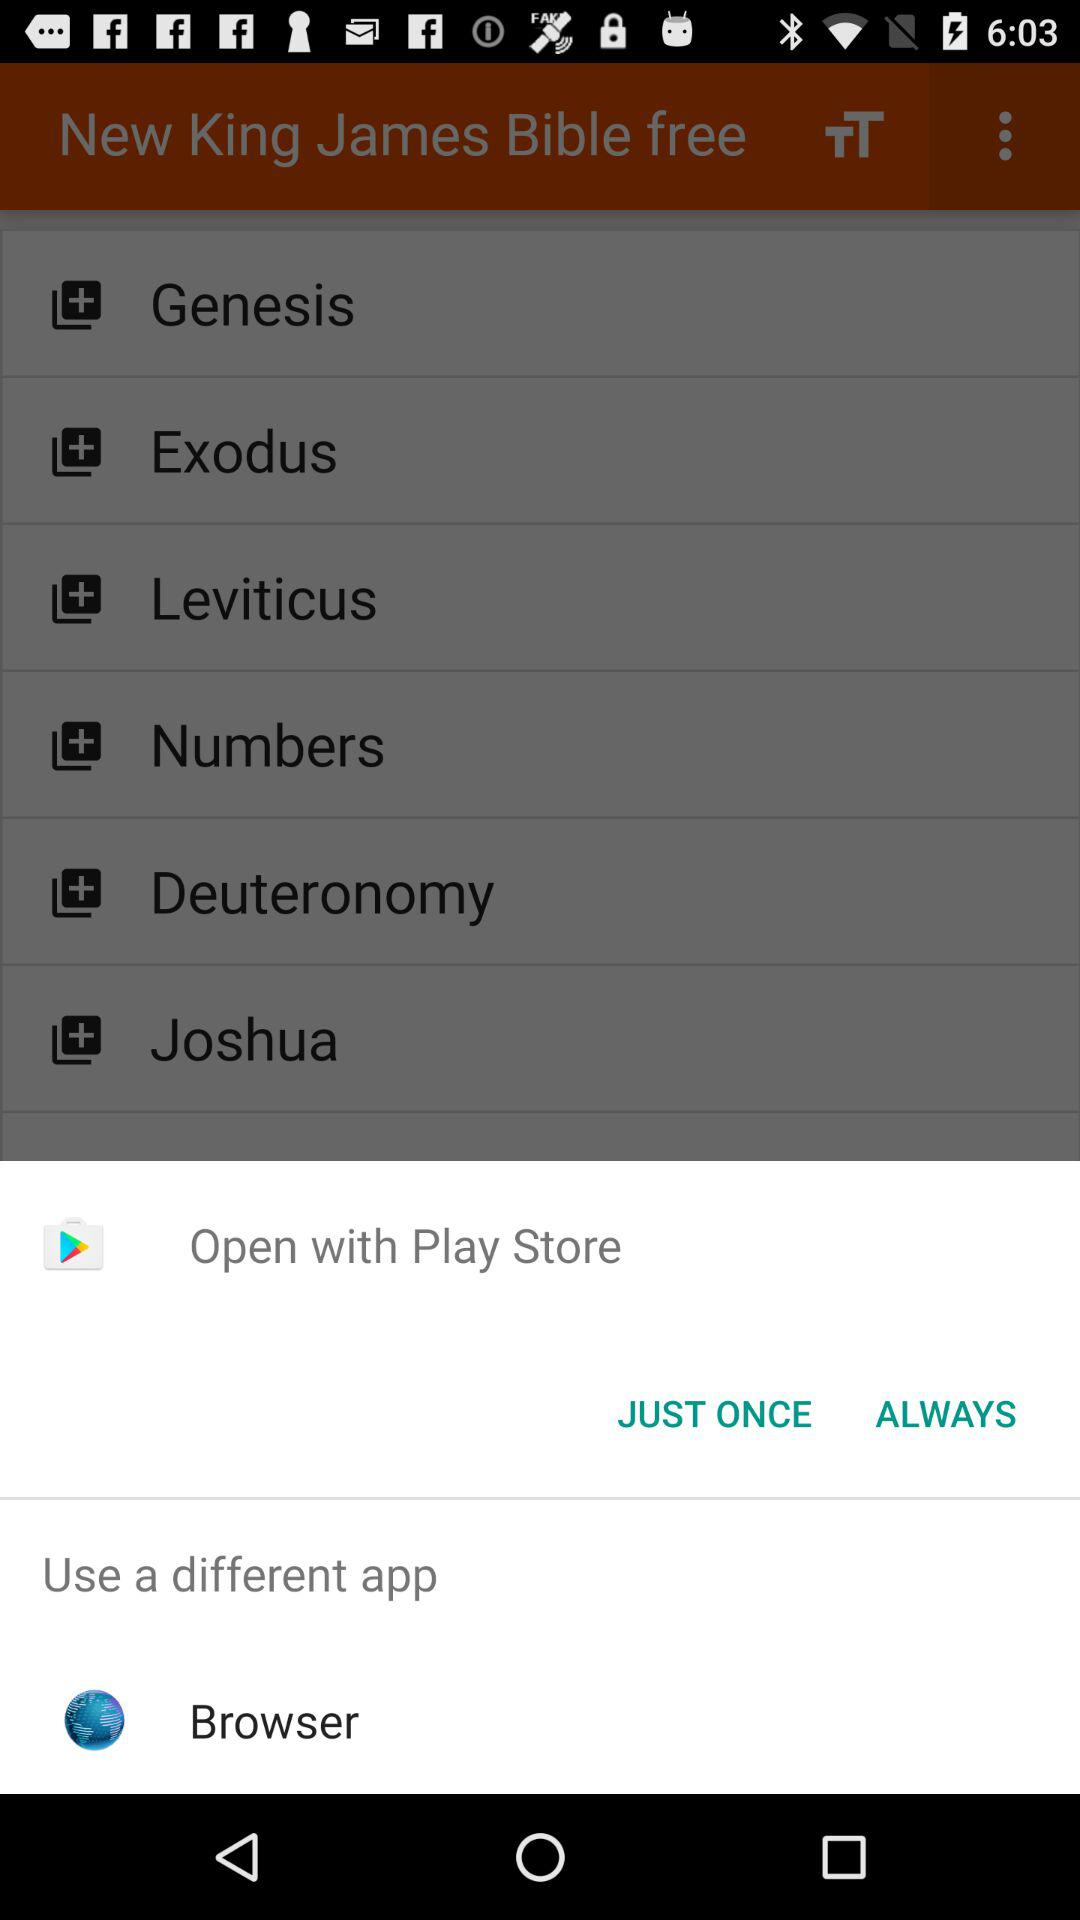What application can I use to open the content? The application that you can use to open the content is "Play Store". 